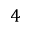Convert formula to latex. <formula><loc_0><loc_0><loc_500><loc_500>4</formula> 